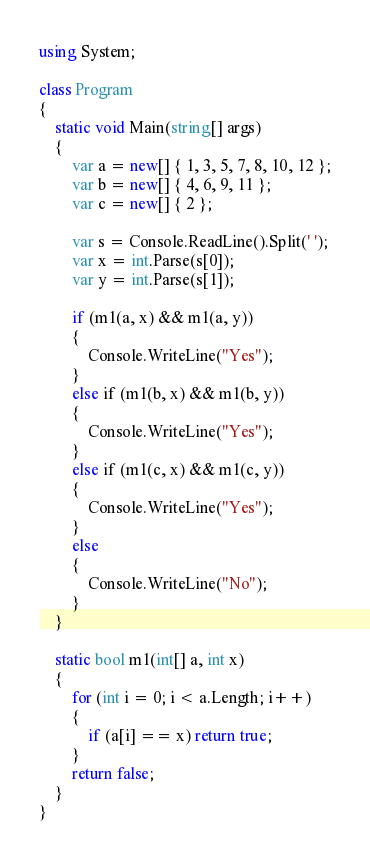Convert code to text. <code><loc_0><loc_0><loc_500><loc_500><_C#_>using System;

class Program
{
    static void Main(string[] args)
    {
        var a = new[] { 1, 3, 5, 7, 8, 10, 12 };
        var b = new[] { 4, 6, 9, 11 };
        var c = new[] { 2 };

        var s = Console.ReadLine().Split(' ');
        var x = int.Parse(s[0]);
        var y = int.Parse(s[1]);

        if (m1(a, x) && m1(a, y))
        {
            Console.WriteLine("Yes");
        }
        else if (m1(b, x) && m1(b, y))
        {
            Console.WriteLine("Yes");
        }
        else if (m1(c, x) && m1(c, y))
        {
            Console.WriteLine("Yes");
        }
        else
        {
            Console.WriteLine("No");
        }
    }

    static bool m1(int[] a, int x)
    {
        for (int i = 0; i < a.Length; i++)
        {
            if (a[i] == x) return true;
        }
        return false;
    }
}
</code> 